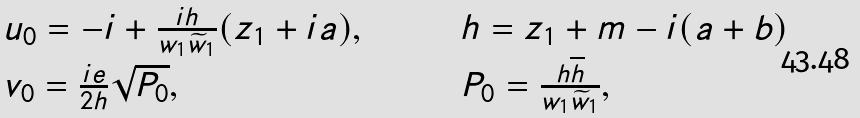<formula> <loc_0><loc_0><loc_500><loc_500>\begin{array} { l c c c c c l } u _ { 0 } = - i + \frac { i h } { w _ { 1 } \widetilde { w } _ { 1 } } ( z _ { 1 } + i a ) , & & & & & & h = z _ { 1 } + m - i ( a + b ) \\ v _ { 0 } = \frac { i e } { 2 h } \sqrt { P _ { 0 } } , & & & & & & P _ { 0 } = \frac { h \overline { h } } { w _ { 1 } \widetilde { w } _ { 1 } } , \end{array}</formula> 